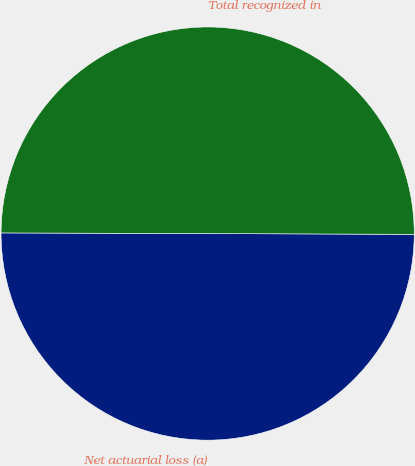Convert chart to OTSL. <chart><loc_0><loc_0><loc_500><loc_500><pie_chart><fcel>Net actuarial loss (a)<fcel>Total recognized in<nl><fcel>49.99%<fcel>50.01%<nl></chart> 